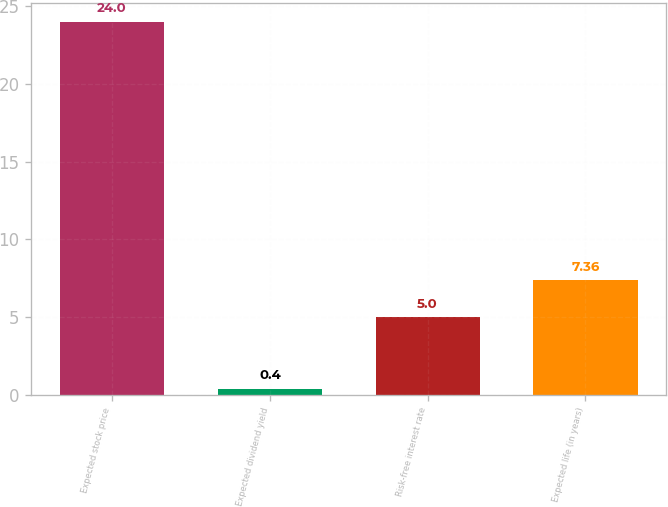Convert chart to OTSL. <chart><loc_0><loc_0><loc_500><loc_500><bar_chart><fcel>Expected stock price<fcel>Expected dividend yield<fcel>Risk-free interest rate<fcel>Expected life (in years)<nl><fcel>24<fcel>0.4<fcel>5<fcel>7.36<nl></chart> 